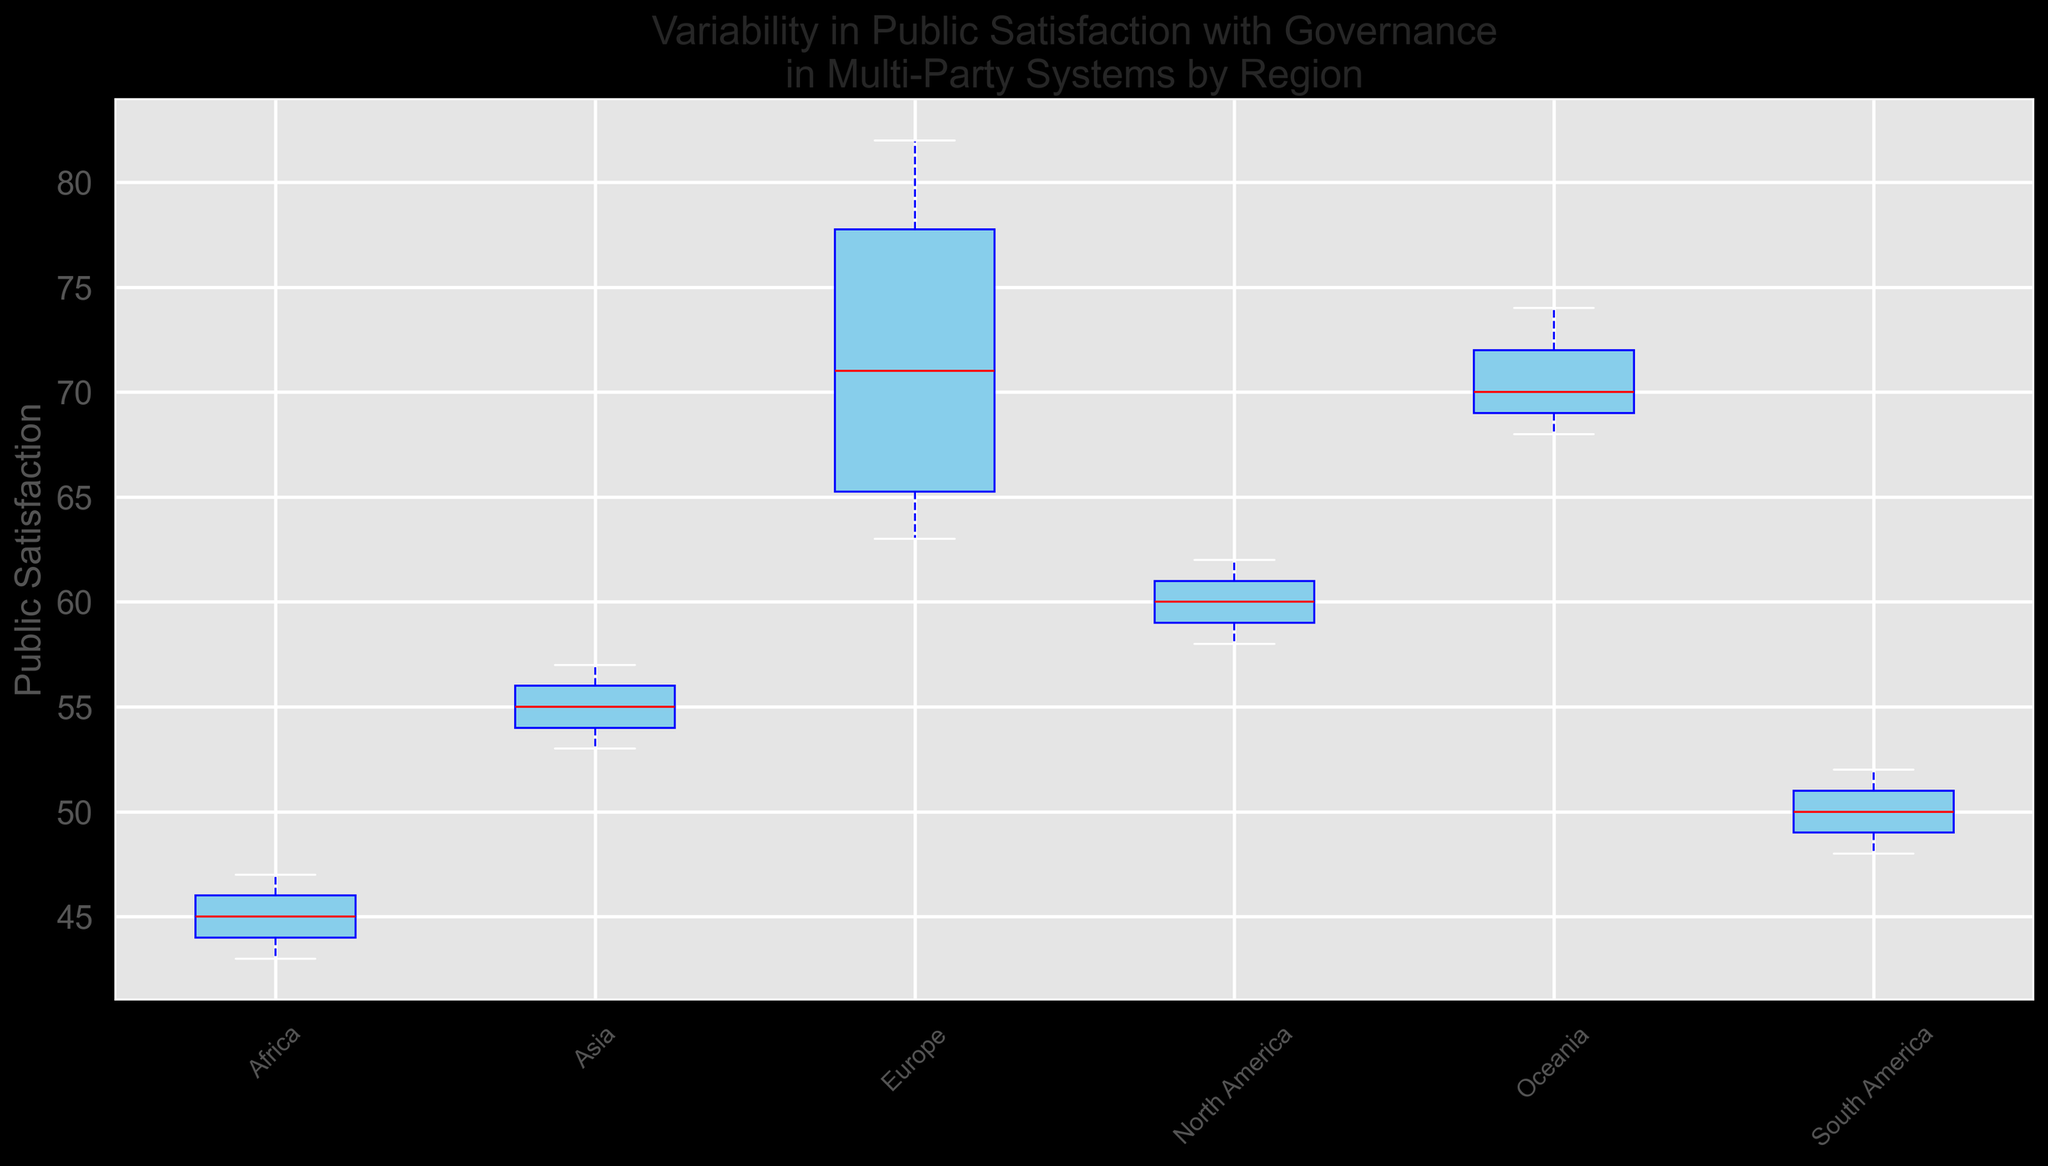Question: Which region has the highest median public satisfaction? Explanation: To determine the region with the highest median public satisfaction, look for the region where the horizontal line (the median) within the box is highest on the y-axis. This represents the highest median value.
Answer: Europe Question: Compare the interquartile range (IQR) of Europe and South America. Which one is larger? Explanation: The IQR is the range between the first quartile (bottom of the box) and the third quartile (top of the box). Compare the height of the boxes for Europe and South America to determine which one is larger.
Answer: Europe Question: What is the lowest public satisfaction value recorded in Africa? Explanation: The lowest public satisfaction value for each region is indicated by the bottom whisker. Identify the lowest point of the whisker for Africa.
Answer: 43 Question: Is the public satisfaction variability higher in Asia or North America? Explanation: Variability can be observed by the length of the whiskers and the size of the box. Longer whiskers and a larger box indicate greater variability. Compare these areas for Asia and North America.
Answer: Asia Question: What visual element indicates the median public satisfaction in each region? Explanation: In a box plot, the median value is shown as a horizontal line within the box. This line is usually a different color (in this plot, it's red) to make it distinguishable.
Answer: Red horizontal line Question: How does the median public satisfaction in Oceania compare to North America? Explanation: Compare the red horizontal lines within the boxes for Oceania and North America to see which is higher on the y-axis, indicating a higher median value.
Answer: Higher Question: What is the range of public satisfaction for Brazil? Explanation: The range is calculated by subtracting the lowest value (bottom whisker) from the highest value (top whisker). Identify these values for Brazil and perform the subtraction.
Answer: 52 - 48 = 4 Question: Which region shows the least variability in public satisfaction? Explanation: The region with the least variability will have the shortest whiskers and the smallest box. Look for the region where the box and whiskers are smallest.
Answer: Europe Question: By looking at the position and size of the boxes and whiskers, which region appears to have the most consistent level of public satisfaction? Explanation: Consistency is indicated by smaller boxes and shorter whiskers. Identify the region with these characteristics.
Answer: Europe 